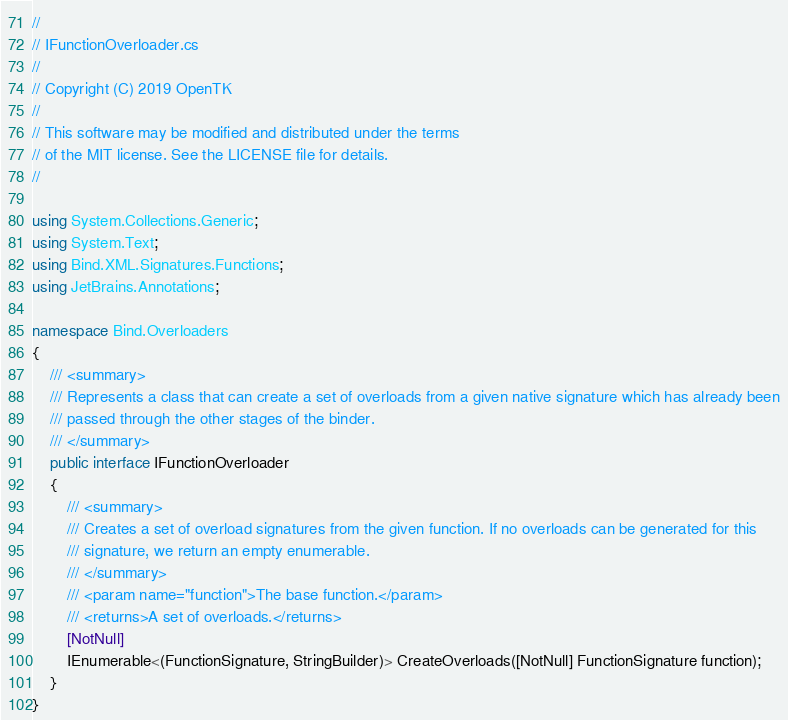<code> <loc_0><loc_0><loc_500><loc_500><_C#_>//
// IFunctionOverloader.cs
//
// Copyright (C) 2019 OpenTK
//
// This software may be modified and distributed under the terms
// of the MIT license. See the LICENSE file for details.
//

using System.Collections.Generic;
using System.Text;
using Bind.XML.Signatures.Functions;
using JetBrains.Annotations;

namespace Bind.Overloaders
{
    /// <summary>
    /// Represents a class that can create a set of overloads from a given native signature which has already been
    /// passed through the other stages of the binder.
    /// </summary>
    public interface IFunctionOverloader
    {
        /// <summary>
        /// Creates a set of overload signatures from the given function. If no overloads can be generated for this
        /// signature, we return an empty enumerable.
        /// </summary>
        /// <param name="function">The base function.</param>
        /// <returns>A set of overloads.</returns>
        [NotNull]
        IEnumerable<(FunctionSignature, StringBuilder)> CreateOverloads([NotNull] FunctionSignature function);
    }
}
</code> 